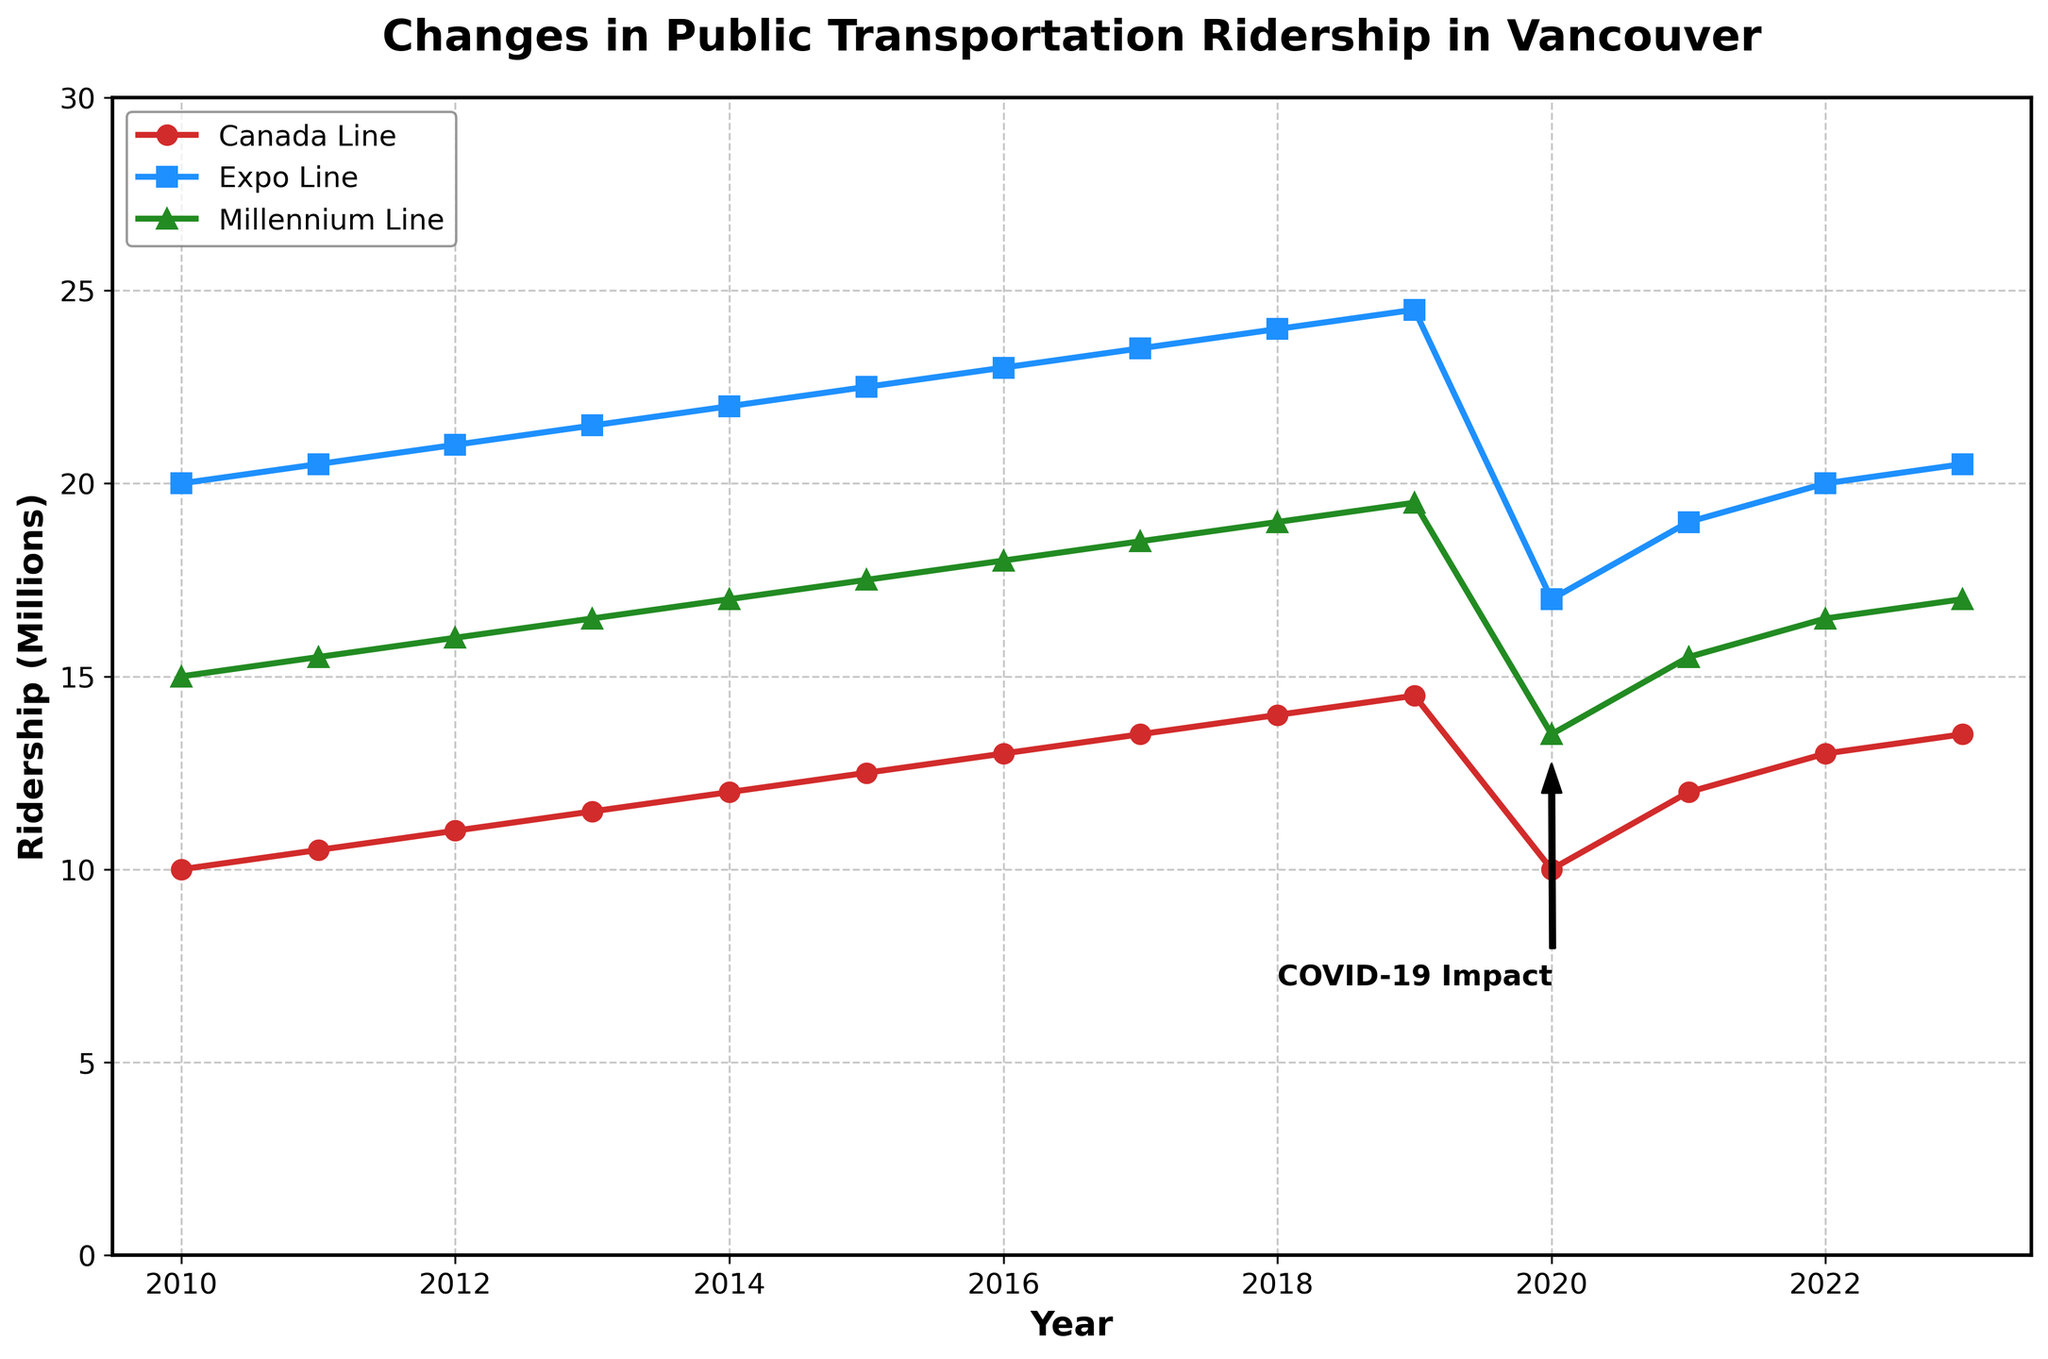What is the title of the figure? The title is typically located at the top of the figure, often in a larger and bold font.
Answer: Changes in Public Transportation Ridership in Vancouver What is the ridership (in millions) for the Canada Line in 2020? Locate the point for the year 2020 on the x-axis, then find where it meets the Canada Line plot and read the y-axis value.
Answer: 10 million In which year did the Millennium Line reach 18 million riders? Locate the y-axis value of 18 million and find the corresponding year on the x-axis for the Millennium Line.
Answer: 2016 How much did the Expo Line ridership change from 2019 to 2020? Subtract the ridership value for the Expo Line in 2020 from that in 2019.
Answer: 7.5 million Which transit line had the smallest decrease in ridership in 2020 compared to 2019? Compare the drop in ridership between 2019 and 2020 for all lines and identify the smallest drop.
Answer: Canada Line What color is used to plot the Expo Line ridership? Observe the color of the line labeled "Expo Line" in the legend.
Answer: Blue How did the ridership of the Canada Line change from 2011 to 2013? Subtract the 2011 ridership value from the 2013 ridership value for the Canada Line.
Answer: Increased by 1 million Which transit line had the lowest ridership in 2023? Compare the ridership values for all three transit lines in 2023 and identify the lowest one.
Answer: Millennium Line By how much did the Canada Line's ridership increase in 2021 compared to 2020? Subtract the ridership value for 2020 from that for 2021 for the Canada Line.
Answer: 2 million Which year shows the annotation for "COVID-19 Impact"? Locate the year indicated by the arrow and annotation on the plot.
Answer: 2020 